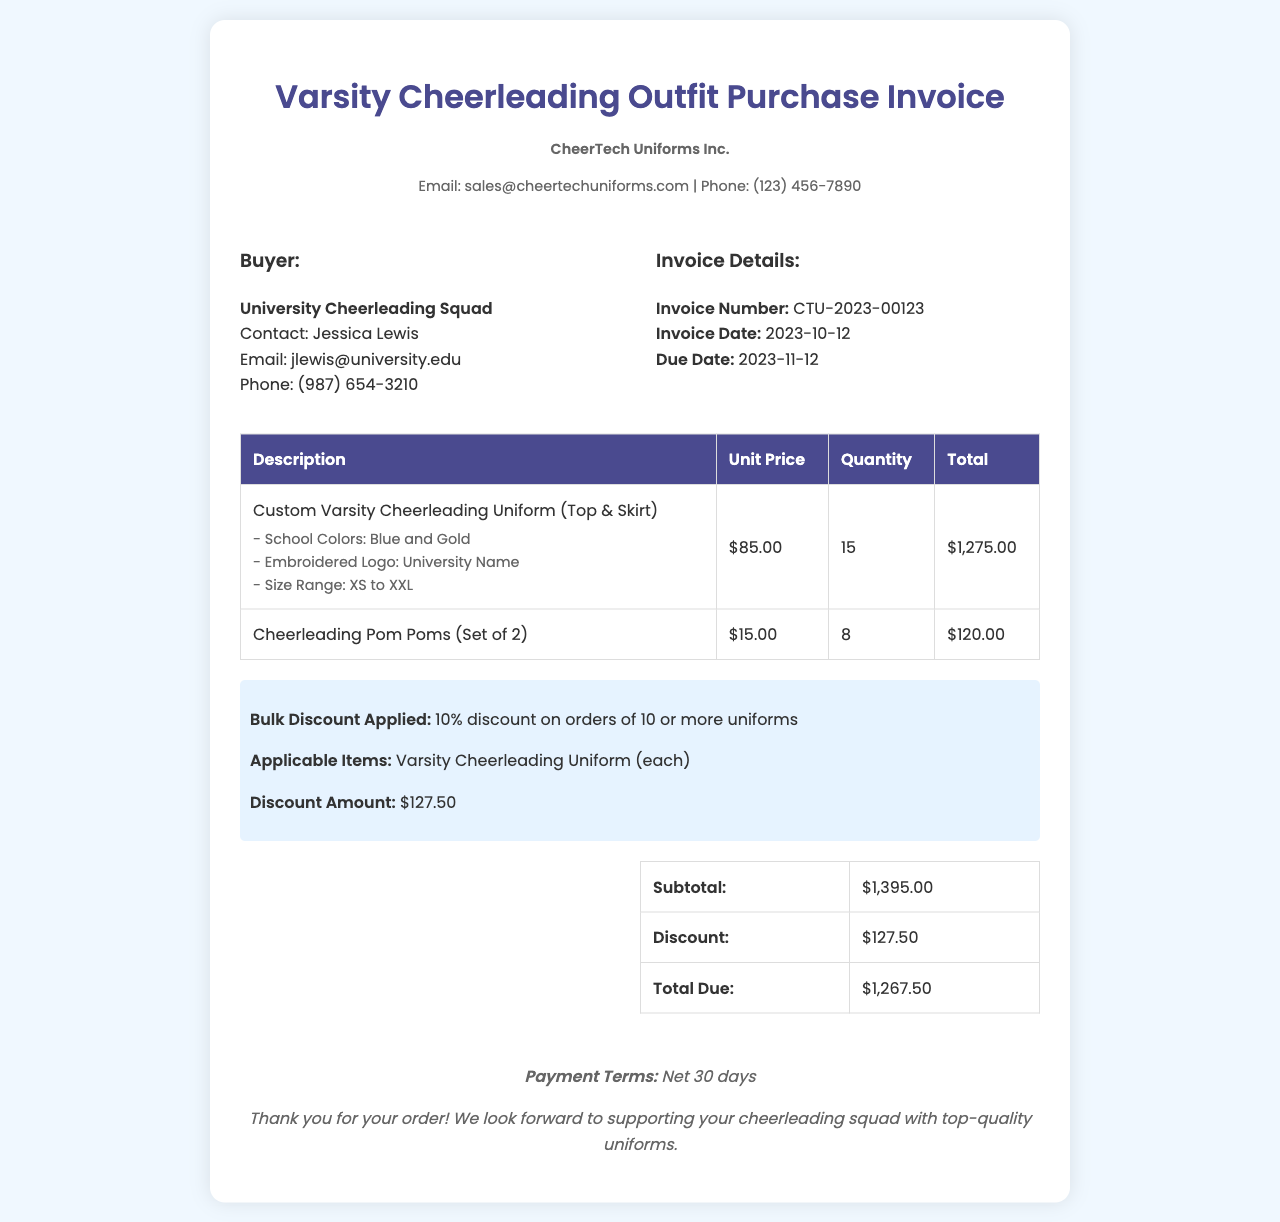What is the buyer's contact name? The buyer's contact name is listed as Jessica Lewis in the document.
Answer: Jessica Lewis What is the total due amount? The total due amount is the final amount after applying the discount, which is shown in the summary section.
Answer: $1,267.50 What discount percentage was applied? The document states that a 10% discount was applied on orders of 10 or more uniforms.
Answer: 10% What is the invoice date? The invoice date is specified in the invoice details section of the document.
Answer: 2023-10-12 How many cheerleading uniforms were ordered? The quantity of cheerleading uniforms ordered is explicitly provided in the details of the line items in the document.
Answer: 15 What is the vendor's email address? The vendor's email address is provided in the vendor information section of the document.
Answer: sales@cheertechuniforms.com What type of items received a bulk discount? The document specifies that only the Varsity Cheerleading Uniform is eligible for the bulk discount.
Answer: Varsity Cheerleading Uniform What payment terms are mentioned? The payment terms are stated at the end of the document, indicating when payment is due.
Answer: Net 30 days How many sets of pom poms were ordered? The document lists the quantity of pom poms ordered in the line item details.
Answer: 8 